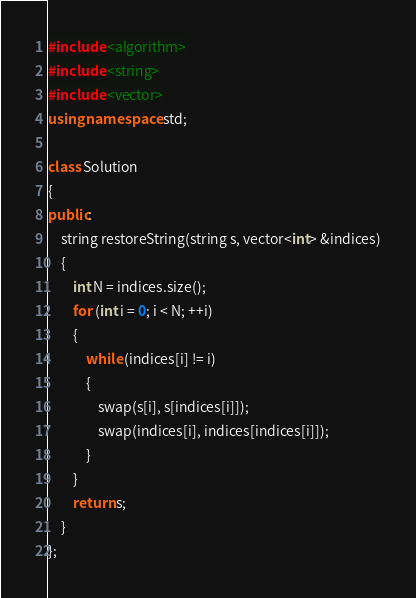<code> <loc_0><loc_0><loc_500><loc_500><_C++_>#include <algorithm>
#include <string>
#include <vector>
using namespace std;

class Solution
{
public:
	string restoreString(string s, vector<int> &indices)
	{
		int N = indices.size();
		for (int i = 0; i < N; ++i)
		{
			while (indices[i] != i)
			{
				swap(s[i], s[indices[i]]);
				swap(indices[i], indices[indices[i]]);
			}
		}
		return s;
	}
};</code> 